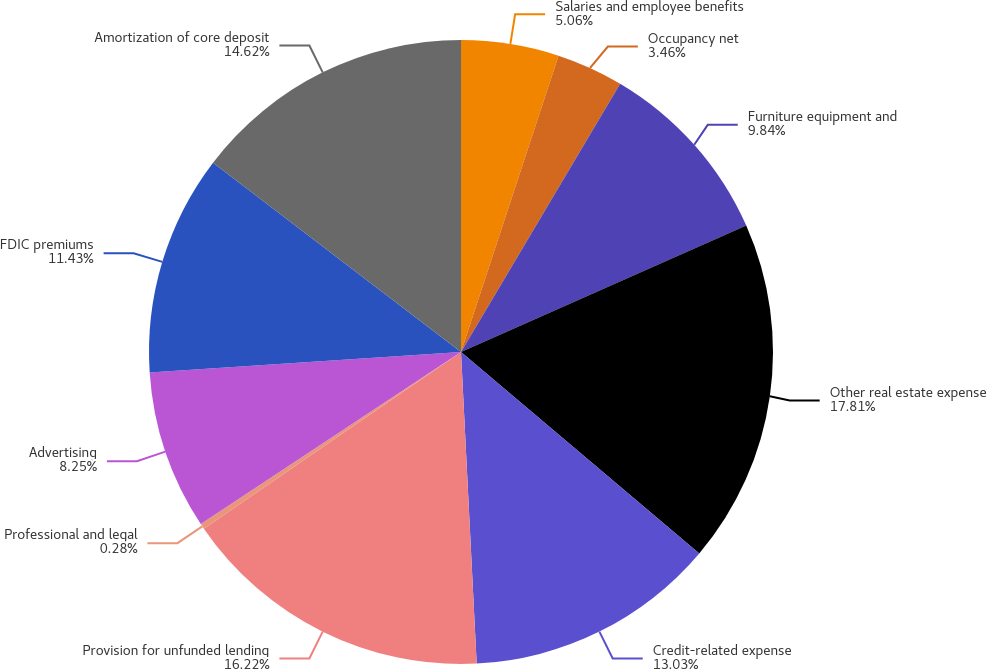<chart> <loc_0><loc_0><loc_500><loc_500><pie_chart><fcel>Salaries and employee benefits<fcel>Occupancy net<fcel>Furniture equipment and<fcel>Other real estate expense<fcel>Credit-related expense<fcel>Provision for unfunded lending<fcel>Professional and legal<fcel>Advertising<fcel>FDIC premiums<fcel>Amortization of core deposit<nl><fcel>5.06%<fcel>3.46%<fcel>9.84%<fcel>17.81%<fcel>13.03%<fcel>16.22%<fcel>0.28%<fcel>8.25%<fcel>11.43%<fcel>14.62%<nl></chart> 